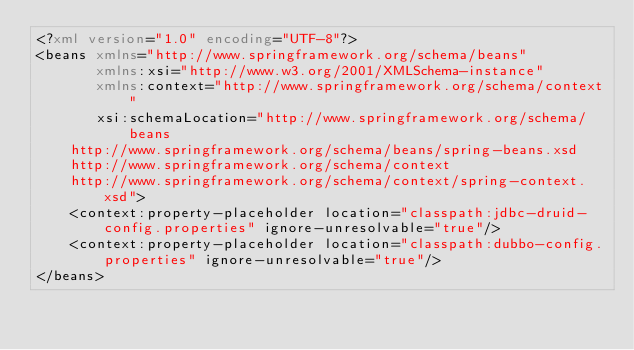Convert code to text. <code><loc_0><loc_0><loc_500><loc_500><_XML_><?xml version="1.0" encoding="UTF-8"?>
<beans xmlns="http://www.springframework.org/schema/beans"
       xmlns:xsi="http://www.w3.org/2001/XMLSchema-instance"
       xmlns:context="http://www.springframework.org/schema/context"
       xsi:schemaLocation="http://www.springframework.org/schema/beans
		http://www.springframework.org/schema/beans/spring-beans.xsd
		http://www.springframework.org/schema/context
		http://www.springframework.org/schema/context/spring-context.xsd">
    <context:property-placeholder location="classpath:jdbc-druid-config.properties" ignore-unresolvable="true"/>
    <context:property-placeholder location="classpath:dubbo-config.properties" ignore-unresolvable="true"/>
</beans></code> 